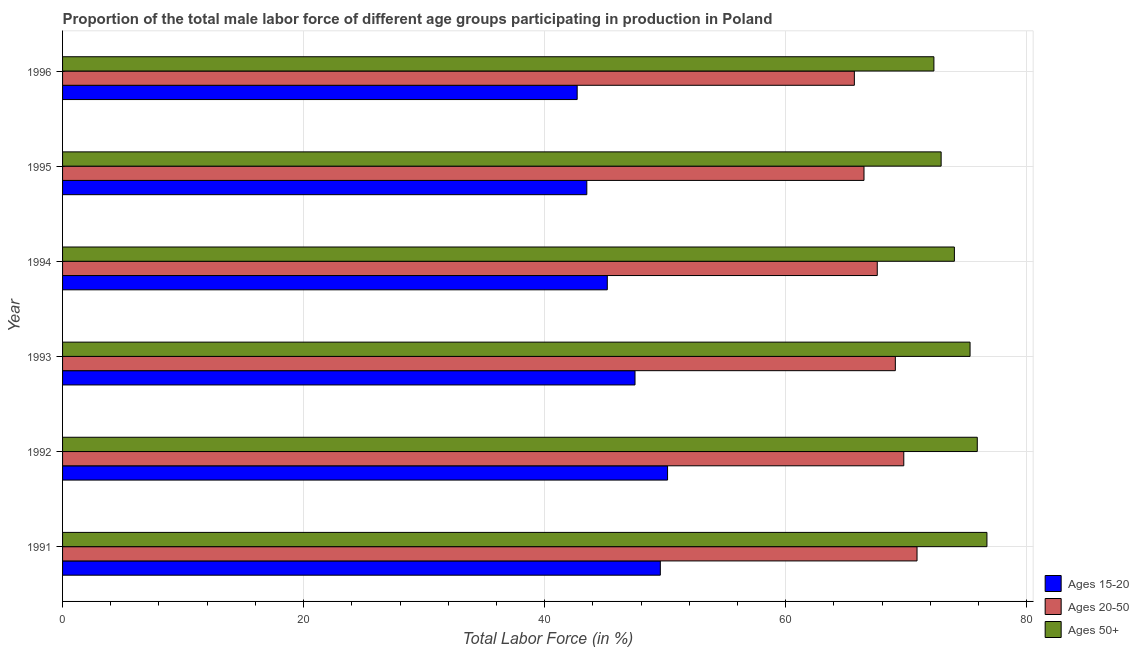How many different coloured bars are there?
Ensure brevity in your answer.  3. Are the number of bars on each tick of the Y-axis equal?
Provide a short and direct response. Yes. How many bars are there on the 6th tick from the top?
Give a very brief answer. 3. How many bars are there on the 3rd tick from the bottom?
Your answer should be compact. 3. What is the label of the 4th group of bars from the top?
Offer a terse response. 1993. What is the percentage of male labor force within the age group 20-50 in 1994?
Offer a very short reply. 67.6. Across all years, what is the maximum percentage of male labor force within the age group 20-50?
Provide a succinct answer. 70.9. Across all years, what is the minimum percentage of male labor force above age 50?
Give a very brief answer. 72.3. In which year was the percentage of male labor force within the age group 15-20 minimum?
Your answer should be compact. 1996. What is the total percentage of male labor force within the age group 15-20 in the graph?
Your answer should be compact. 278.7. What is the difference between the percentage of male labor force within the age group 15-20 in 1994 and the percentage of male labor force above age 50 in 1996?
Your answer should be very brief. -27.1. What is the average percentage of male labor force above age 50 per year?
Give a very brief answer. 74.52. In the year 1996, what is the difference between the percentage of male labor force above age 50 and percentage of male labor force within the age group 15-20?
Offer a very short reply. 29.6. What is the ratio of the percentage of male labor force within the age group 20-50 in 1993 to that in 1996?
Your answer should be very brief. 1.05. What is the difference between the highest and the second highest percentage of male labor force within the age group 15-20?
Offer a terse response. 0.6. In how many years, is the percentage of male labor force above age 50 greater than the average percentage of male labor force above age 50 taken over all years?
Your response must be concise. 3. What does the 2nd bar from the top in 1995 represents?
Your answer should be compact. Ages 20-50. What does the 2nd bar from the bottom in 1996 represents?
Give a very brief answer. Ages 20-50. Is it the case that in every year, the sum of the percentage of male labor force within the age group 15-20 and percentage of male labor force within the age group 20-50 is greater than the percentage of male labor force above age 50?
Offer a terse response. Yes. Are all the bars in the graph horizontal?
Ensure brevity in your answer.  Yes. How many years are there in the graph?
Provide a succinct answer. 6. What is the difference between two consecutive major ticks on the X-axis?
Offer a very short reply. 20. Are the values on the major ticks of X-axis written in scientific E-notation?
Provide a succinct answer. No. Does the graph contain grids?
Your answer should be compact. Yes. Where does the legend appear in the graph?
Ensure brevity in your answer.  Bottom right. How many legend labels are there?
Your answer should be very brief. 3. What is the title of the graph?
Give a very brief answer. Proportion of the total male labor force of different age groups participating in production in Poland. Does "Capital account" appear as one of the legend labels in the graph?
Offer a very short reply. No. What is the label or title of the Y-axis?
Your answer should be very brief. Year. What is the Total Labor Force (in %) of Ages 15-20 in 1991?
Provide a succinct answer. 49.6. What is the Total Labor Force (in %) in Ages 20-50 in 1991?
Offer a very short reply. 70.9. What is the Total Labor Force (in %) in Ages 50+ in 1991?
Provide a short and direct response. 76.7. What is the Total Labor Force (in %) in Ages 15-20 in 1992?
Offer a terse response. 50.2. What is the Total Labor Force (in %) of Ages 20-50 in 1992?
Give a very brief answer. 69.8. What is the Total Labor Force (in %) of Ages 50+ in 1992?
Keep it short and to the point. 75.9. What is the Total Labor Force (in %) of Ages 15-20 in 1993?
Offer a terse response. 47.5. What is the Total Labor Force (in %) in Ages 20-50 in 1993?
Your answer should be very brief. 69.1. What is the Total Labor Force (in %) in Ages 50+ in 1993?
Make the answer very short. 75.3. What is the Total Labor Force (in %) of Ages 15-20 in 1994?
Offer a terse response. 45.2. What is the Total Labor Force (in %) in Ages 20-50 in 1994?
Give a very brief answer. 67.6. What is the Total Labor Force (in %) of Ages 15-20 in 1995?
Make the answer very short. 43.5. What is the Total Labor Force (in %) of Ages 20-50 in 1995?
Offer a very short reply. 66.5. What is the Total Labor Force (in %) of Ages 50+ in 1995?
Provide a succinct answer. 72.9. What is the Total Labor Force (in %) in Ages 15-20 in 1996?
Offer a terse response. 42.7. What is the Total Labor Force (in %) of Ages 20-50 in 1996?
Your answer should be very brief. 65.7. What is the Total Labor Force (in %) in Ages 50+ in 1996?
Your answer should be very brief. 72.3. Across all years, what is the maximum Total Labor Force (in %) of Ages 15-20?
Provide a short and direct response. 50.2. Across all years, what is the maximum Total Labor Force (in %) of Ages 20-50?
Your answer should be compact. 70.9. Across all years, what is the maximum Total Labor Force (in %) of Ages 50+?
Keep it short and to the point. 76.7. Across all years, what is the minimum Total Labor Force (in %) of Ages 15-20?
Offer a terse response. 42.7. Across all years, what is the minimum Total Labor Force (in %) in Ages 20-50?
Keep it short and to the point. 65.7. Across all years, what is the minimum Total Labor Force (in %) of Ages 50+?
Offer a terse response. 72.3. What is the total Total Labor Force (in %) of Ages 15-20 in the graph?
Offer a terse response. 278.7. What is the total Total Labor Force (in %) in Ages 20-50 in the graph?
Provide a short and direct response. 409.6. What is the total Total Labor Force (in %) of Ages 50+ in the graph?
Make the answer very short. 447.1. What is the difference between the Total Labor Force (in %) in Ages 20-50 in 1991 and that in 1992?
Make the answer very short. 1.1. What is the difference between the Total Labor Force (in %) in Ages 50+ in 1991 and that in 1993?
Keep it short and to the point. 1.4. What is the difference between the Total Labor Force (in %) of Ages 15-20 in 1991 and that in 1994?
Offer a terse response. 4.4. What is the difference between the Total Labor Force (in %) in Ages 50+ in 1991 and that in 1994?
Keep it short and to the point. 2.7. What is the difference between the Total Labor Force (in %) in Ages 20-50 in 1991 and that in 1995?
Keep it short and to the point. 4.4. What is the difference between the Total Labor Force (in %) of Ages 20-50 in 1992 and that in 1993?
Make the answer very short. 0.7. What is the difference between the Total Labor Force (in %) in Ages 50+ in 1992 and that in 1993?
Provide a short and direct response. 0.6. What is the difference between the Total Labor Force (in %) in Ages 15-20 in 1992 and that in 1994?
Ensure brevity in your answer.  5. What is the difference between the Total Labor Force (in %) of Ages 50+ in 1992 and that in 1994?
Offer a terse response. 1.9. What is the difference between the Total Labor Force (in %) in Ages 15-20 in 1992 and that in 1995?
Keep it short and to the point. 6.7. What is the difference between the Total Labor Force (in %) in Ages 20-50 in 1992 and that in 1995?
Ensure brevity in your answer.  3.3. What is the difference between the Total Labor Force (in %) in Ages 50+ in 1992 and that in 1995?
Provide a short and direct response. 3. What is the difference between the Total Labor Force (in %) of Ages 50+ in 1992 and that in 1996?
Ensure brevity in your answer.  3.6. What is the difference between the Total Labor Force (in %) of Ages 20-50 in 1993 and that in 1994?
Give a very brief answer. 1.5. What is the difference between the Total Labor Force (in %) in Ages 15-20 in 1993 and that in 1995?
Make the answer very short. 4. What is the difference between the Total Labor Force (in %) in Ages 20-50 in 1993 and that in 1995?
Provide a short and direct response. 2.6. What is the difference between the Total Labor Force (in %) in Ages 50+ in 1993 and that in 1995?
Your answer should be compact. 2.4. What is the difference between the Total Labor Force (in %) in Ages 20-50 in 1993 and that in 1996?
Provide a short and direct response. 3.4. What is the difference between the Total Labor Force (in %) in Ages 50+ in 1993 and that in 1996?
Give a very brief answer. 3. What is the difference between the Total Labor Force (in %) in Ages 20-50 in 1994 and that in 1996?
Provide a succinct answer. 1.9. What is the difference between the Total Labor Force (in %) of Ages 50+ in 1994 and that in 1996?
Your answer should be compact. 1.7. What is the difference between the Total Labor Force (in %) in Ages 15-20 in 1995 and that in 1996?
Make the answer very short. 0.8. What is the difference between the Total Labor Force (in %) of Ages 20-50 in 1995 and that in 1996?
Offer a very short reply. 0.8. What is the difference between the Total Labor Force (in %) of Ages 50+ in 1995 and that in 1996?
Keep it short and to the point. 0.6. What is the difference between the Total Labor Force (in %) in Ages 15-20 in 1991 and the Total Labor Force (in %) in Ages 20-50 in 1992?
Keep it short and to the point. -20.2. What is the difference between the Total Labor Force (in %) in Ages 15-20 in 1991 and the Total Labor Force (in %) in Ages 50+ in 1992?
Your response must be concise. -26.3. What is the difference between the Total Labor Force (in %) in Ages 15-20 in 1991 and the Total Labor Force (in %) in Ages 20-50 in 1993?
Your response must be concise. -19.5. What is the difference between the Total Labor Force (in %) in Ages 15-20 in 1991 and the Total Labor Force (in %) in Ages 50+ in 1993?
Your answer should be compact. -25.7. What is the difference between the Total Labor Force (in %) in Ages 20-50 in 1991 and the Total Labor Force (in %) in Ages 50+ in 1993?
Your response must be concise. -4.4. What is the difference between the Total Labor Force (in %) in Ages 15-20 in 1991 and the Total Labor Force (in %) in Ages 20-50 in 1994?
Your answer should be compact. -18. What is the difference between the Total Labor Force (in %) in Ages 15-20 in 1991 and the Total Labor Force (in %) in Ages 50+ in 1994?
Ensure brevity in your answer.  -24.4. What is the difference between the Total Labor Force (in %) in Ages 20-50 in 1991 and the Total Labor Force (in %) in Ages 50+ in 1994?
Ensure brevity in your answer.  -3.1. What is the difference between the Total Labor Force (in %) in Ages 15-20 in 1991 and the Total Labor Force (in %) in Ages 20-50 in 1995?
Offer a terse response. -16.9. What is the difference between the Total Labor Force (in %) of Ages 15-20 in 1991 and the Total Labor Force (in %) of Ages 50+ in 1995?
Your answer should be very brief. -23.3. What is the difference between the Total Labor Force (in %) of Ages 20-50 in 1991 and the Total Labor Force (in %) of Ages 50+ in 1995?
Provide a short and direct response. -2. What is the difference between the Total Labor Force (in %) in Ages 15-20 in 1991 and the Total Labor Force (in %) in Ages 20-50 in 1996?
Offer a very short reply. -16.1. What is the difference between the Total Labor Force (in %) of Ages 15-20 in 1991 and the Total Labor Force (in %) of Ages 50+ in 1996?
Your answer should be very brief. -22.7. What is the difference between the Total Labor Force (in %) of Ages 20-50 in 1991 and the Total Labor Force (in %) of Ages 50+ in 1996?
Give a very brief answer. -1.4. What is the difference between the Total Labor Force (in %) of Ages 15-20 in 1992 and the Total Labor Force (in %) of Ages 20-50 in 1993?
Your answer should be very brief. -18.9. What is the difference between the Total Labor Force (in %) of Ages 15-20 in 1992 and the Total Labor Force (in %) of Ages 50+ in 1993?
Ensure brevity in your answer.  -25.1. What is the difference between the Total Labor Force (in %) of Ages 15-20 in 1992 and the Total Labor Force (in %) of Ages 20-50 in 1994?
Offer a very short reply. -17.4. What is the difference between the Total Labor Force (in %) of Ages 15-20 in 1992 and the Total Labor Force (in %) of Ages 50+ in 1994?
Provide a succinct answer. -23.8. What is the difference between the Total Labor Force (in %) in Ages 20-50 in 1992 and the Total Labor Force (in %) in Ages 50+ in 1994?
Give a very brief answer. -4.2. What is the difference between the Total Labor Force (in %) in Ages 15-20 in 1992 and the Total Labor Force (in %) in Ages 20-50 in 1995?
Provide a short and direct response. -16.3. What is the difference between the Total Labor Force (in %) in Ages 15-20 in 1992 and the Total Labor Force (in %) in Ages 50+ in 1995?
Provide a succinct answer. -22.7. What is the difference between the Total Labor Force (in %) in Ages 15-20 in 1992 and the Total Labor Force (in %) in Ages 20-50 in 1996?
Give a very brief answer. -15.5. What is the difference between the Total Labor Force (in %) of Ages 15-20 in 1992 and the Total Labor Force (in %) of Ages 50+ in 1996?
Make the answer very short. -22.1. What is the difference between the Total Labor Force (in %) of Ages 20-50 in 1992 and the Total Labor Force (in %) of Ages 50+ in 1996?
Your answer should be compact. -2.5. What is the difference between the Total Labor Force (in %) of Ages 15-20 in 1993 and the Total Labor Force (in %) of Ages 20-50 in 1994?
Make the answer very short. -20.1. What is the difference between the Total Labor Force (in %) of Ages 15-20 in 1993 and the Total Labor Force (in %) of Ages 50+ in 1994?
Make the answer very short. -26.5. What is the difference between the Total Labor Force (in %) in Ages 20-50 in 1993 and the Total Labor Force (in %) in Ages 50+ in 1994?
Your response must be concise. -4.9. What is the difference between the Total Labor Force (in %) of Ages 15-20 in 1993 and the Total Labor Force (in %) of Ages 50+ in 1995?
Provide a short and direct response. -25.4. What is the difference between the Total Labor Force (in %) in Ages 20-50 in 1993 and the Total Labor Force (in %) in Ages 50+ in 1995?
Ensure brevity in your answer.  -3.8. What is the difference between the Total Labor Force (in %) in Ages 15-20 in 1993 and the Total Labor Force (in %) in Ages 20-50 in 1996?
Give a very brief answer. -18.2. What is the difference between the Total Labor Force (in %) of Ages 15-20 in 1993 and the Total Labor Force (in %) of Ages 50+ in 1996?
Your answer should be compact. -24.8. What is the difference between the Total Labor Force (in %) in Ages 20-50 in 1993 and the Total Labor Force (in %) in Ages 50+ in 1996?
Provide a succinct answer. -3.2. What is the difference between the Total Labor Force (in %) in Ages 15-20 in 1994 and the Total Labor Force (in %) in Ages 20-50 in 1995?
Offer a terse response. -21.3. What is the difference between the Total Labor Force (in %) in Ages 15-20 in 1994 and the Total Labor Force (in %) in Ages 50+ in 1995?
Offer a very short reply. -27.7. What is the difference between the Total Labor Force (in %) of Ages 15-20 in 1994 and the Total Labor Force (in %) of Ages 20-50 in 1996?
Make the answer very short. -20.5. What is the difference between the Total Labor Force (in %) of Ages 15-20 in 1994 and the Total Labor Force (in %) of Ages 50+ in 1996?
Make the answer very short. -27.1. What is the difference between the Total Labor Force (in %) in Ages 20-50 in 1994 and the Total Labor Force (in %) in Ages 50+ in 1996?
Keep it short and to the point. -4.7. What is the difference between the Total Labor Force (in %) in Ages 15-20 in 1995 and the Total Labor Force (in %) in Ages 20-50 in 1996?
Give a very brief answer. -22.2. What is the difference between the Total Labor Force (in %) of Ages 15-20 in 1995 and the Total Labor Force (in %) of Ages 50+ in 1996?
Your response must be concise. -28.8. What is the average Total Labor Force (in %) in Ages 15-20 per year?
Offer a terse response. 46.45. What is the average Total Labor Force (in %) of Ages 20-50 per year?
Provide a succinct answer. 68.27. What is the average Total Labor Force (in %) of Ages 50+ per year?
Your answer should be very brief. 74.52. In the year 1991, what is the difference between the Total Labor Force (in %) in Ages 15-20 and Total Labor Force (in %) in Ages 20-50?
Provide a short and direct response. -21.3. In the year 1991, what is the difference between the Total Labor Force (in %) of Ages 15-20 and Total Labor Force (in %) of Ages 50+?
Offer a very short reply. -27.1. In the year 1992, what is the difference between the Total Labor Force (in %) of Ages 15-20 and Total Labor Force (in %) of Ages 20-50?
Your answer should be very brief. -19.6. In the year 1992, what is the difference between the Total Labor Force (in %) of Ages 15-20 and Total Labor Force (in %) of Ages 50+?
Ensure brevity in your answer.  -25.7. In the year 1993, what is the difference between the Total Labor Force (in %) in Ages 15-20 and Total Labor Force (in %) in Ages 20-50?
Offer a terse response. -21.6. In the year 1993, what is the difference between the Total Labor Force (in %) in Ages 15-20 and Total Labor Force (in %) in Ages 50+?
Offer a terse response. -27.8. In the year 1994, what is the difference between the Total Labor Force (in %) of Ages 15-20 and Total Labor Force (in %) of Ages 20-50?
Your answer should be very brief. -22.4. In the year 1994, what is the difference between the Total Labor Force (in %) in Ages 15-20 and Total Labor Force (in %) in Ages 50+?
Make the answer very short. -28.8. In the year 1994, what is the difference between the Total Labor Force (in %) in Ages 20-50 and Total Labor Force (in %) in Ages 50+?
Give a very brief answer. -6.4. In the year 1995, what is the difference between the Total Labor Force (in %) of Ages 15-20 and Total Labor Force (in %) of Ages 20-50?
Ensure brevity in your answer.  -23. In the year 1995, what is the difference between the Total Labor Force (in %) of Ages 15-20 and Total Labor Force (in %) of Ages 50+?
Your response must be concise. -29.4. In the year 1995, what is the difference between the Total Labor Force (in %) of Ages 20-50 and Total Labor Force (in %) of Ages 50+?
Provide a succinct answer. -6.4. In the year 1996, what is the difference between the Total Labor Force (in %) of Ages 15-20 and Total Labor Force (in %) of Ages 20-50?
Ensure brevity in your answer.  -23. In the year 1996, what is the difference between the Total Labor Force (in %) in Ages 15-20 and Total Labor Force (in %) in Ages 50+?
Give a very brief answer. -29.6. In the year 1996, what is the difference between the Total Labor Force (in %) in Ages 20-50 and Total Labor Force (in %) in Ages 50+?
Give a very brief answer. -6.6. What is the ratio of the Total Labor Force (in %) in Ages 20-50 in 1991 to that in 1992?
Your answer should be compact. 1.02. What is the ratio of the Total Labor Force (in %) of Ages 50+ in 1991 to that in 1992?
Your answer should be very brief. 1.01. What is the ratio of the Total Labor Force (in %) of Ages 15-20 in 1991 to that in 1993?
Ensure brevity in your answer.  1.04. What is the ratio of the Total Labor Force (in %) in Ages 20-50 in 1991 to that in 1993?
Give a very brief answer. 1.03. What is the ratio of the Total Labor Force (in %) in Ages 50+ in 1991 to that in 1993?
Offer a terse response. 1.02. What is the ratio of the Total Labor Force (in %) of Ages 15-20 in 1991 to that in 1994?
Provide a succinct answer. 1.1. What is the ratio of the Total Labor Force (in %) of Ages 20-50 in 1991 to that in 1994?
Your answer should be compact. 1.05. What is the ratio of the Total Labor Force (in %) in Ages 50+ in 1991 to that in 1994?
Ensure brevity in your answer.  1.04. What is the ratio of the Total Labor Force (in %) of Ages 15-20 in 1991 to that in 1995?
Ensure brevity in your answer.  1.14. What is the ratio of the Total Labor Force (in %) in Ages 20-50 in 1991 to that in 1995?
Your answer should be very brief. 1.07. What is the ratio of the Total Labor Force (in %) of Ages 50+ in 1991 to that in 1995?
Offer a terse response. 1.05. What is the ratio of the Total Labor Force (in %) of Ages 15-20 in 1991 to that in 1996?
Make the answer very short. 1.16. What is the ratio of the Total Labor Force (in %) of Ages 20-50 in 1991 to that in 1996?
Your answer should be very brief. 1.08. What is the ratio of the Total Labor Force (in %) in Ages 50+ in 1991 to that in 1996?
Keep it short and to the point. 1.06. What is the ratio of the Total Labor Force (in %) of Ages 15-20 in 1992 to that in 1993?
Provide a short and direct response. 1.06. What is the ratio of the Total Labor Force (in %) of Ages 50+ in 1992 to that in 1993?
Keep it short and to the point. 1.01. What is the ratio of the Total Labor Force (in %) in Ages 15-20 in 1992 to that in 1994?
Give a very brief answer. 1.11. What is the ratio of the Total Labor Force (in %) in Ages 20-50 in 1992 to that in 1994?
Ensure brevity in your answer.  1.03. What is the ratio of the Total Labor Force (in %) of Ages 50+ in 1992 to that in 1994?
Offer a terse response. 1.03. What is the ratio of the Total Labor Force (in %) in Ages 15-20 in 1992 to that in 1995?
Give a very brief answer. 1.15. What is the ratio of the Total Labor Force (in %) in Ages 20-50 in 1992 to that in 1995?
Your response must be concise. 1.05. What is the ratio of the Total Labor Force (in %) in Ages 50+ in 1992 to that in 1995?
Make the answer very short. 1.04. What is the ratio of the Total Labor Force (in %) of Ages 15-20 in 1992 to that in 1996?
Keep it short and to the point. 1.18. What is the ratio of the Total Labor Force (in %) of Ages 20-50 in 1992 to that in 1996?
Give a very brief answer. 1.06. What is the ratio of the Total Labor Force (in %) in Ages 50+ in 1992 to that in 1996?
Ensure brevity in your answer.  1.05. What is the ratio of the Total Labor Force (in %) of Ages 15-20 in 1993 to that in 1994?
Offer a terse response. 1.05. What is the ratio of the Total Labor Force (in %) of Ages 20-50 in 1993 to that in 1994?
Your answer should be very brief. 1.02. What is the ratio of the Total Labor Force (in %) of Ages 50+ in 1993 to that in 1994?
Give a very brief answer. 1.02. What is the ratio of the Total Labor Force (in %) in Ages 15-20 in 1993 to that in 1995?
Your response must be concise. 1.09. What is the ratio of the Total Labor Force (in %) in Ages 20-50 in 1993 to that in 1995?
Your answer should be compact. 1.04. What is the ratio of the Total Labor Force (in %) in Ages 50+ in 1993 to that in 1995?
Your response must be concise. 1.03. What is the ratio of the Total Labor Force (in %) in Ages 15-20 in 1993 to that in 1996?
Provide a short and direct response. 1.11. What is the ratio of the Total Labor Force (in %) in Ages 20-50 in 1993 to that in 1996?
Keep it short and to the point. 1.05. What is the ratio of the Total Labor Force (in %) of Ages 50+ in 1993 to that in 1996?
Your answer should be very brief. 1.04. What is the ratio of the Total Labor Force (in %) of Ages 15-20 in 1994 to that in 1995?
Offer a very short reply. 1.04. What is the ratio of the Total Labor Force (in %) of Ages 20-50 in 1994 to that in 1995?
Your answer should be very brief. 1.02. What is the ratio of the Total Labor Force (in %) of Ages 50+ in 1994 to that in 1995?
Provide a succinct answer. 1.02. What is the ratio of the Total Labor Force (in %) in Ages 15-20 in 1994 to that in 1996?
Make the answer very short. 1.06. What is the ratio of the Total Labor Force (in %) of Ages 20-50 in 1994 to that in 1996?
Keep it short and to the point. 1.03. What is the ratio of the Total Labor Force (in %) in Ages 50+ in 1994 to that in 1996?
Ensure brevity in your answer.  1.02. What is the ratio of the Total Labor Force (in %) of Ages 15-20 in 1995 to that in 1996?
Keep it short and to the point. 1.02. What is the ratio of the Total Labor Force (in %) of Ages 20-50 in 1995 to that in 1996?
Make the answer very short. 1.01. What is the ratio of the Total Labor Force (in %) in Ages 50+ in 1995 to that in 1996?
Offer a very short reply. 1.01. What is the difference between the highest and the second highest Total Labor Force (in %) of Ages 15-20?
Give a very brief answer. 0.6. What is the difference between the highest and the second highest Total Labor Force (in %) in Ages 20-50?
Keep it short and to the point. 1.1. What is the difference between the highest and the lowest Total Labor Force (in %) in Ages 50+?
Provide a short and direct response. 4.4. 